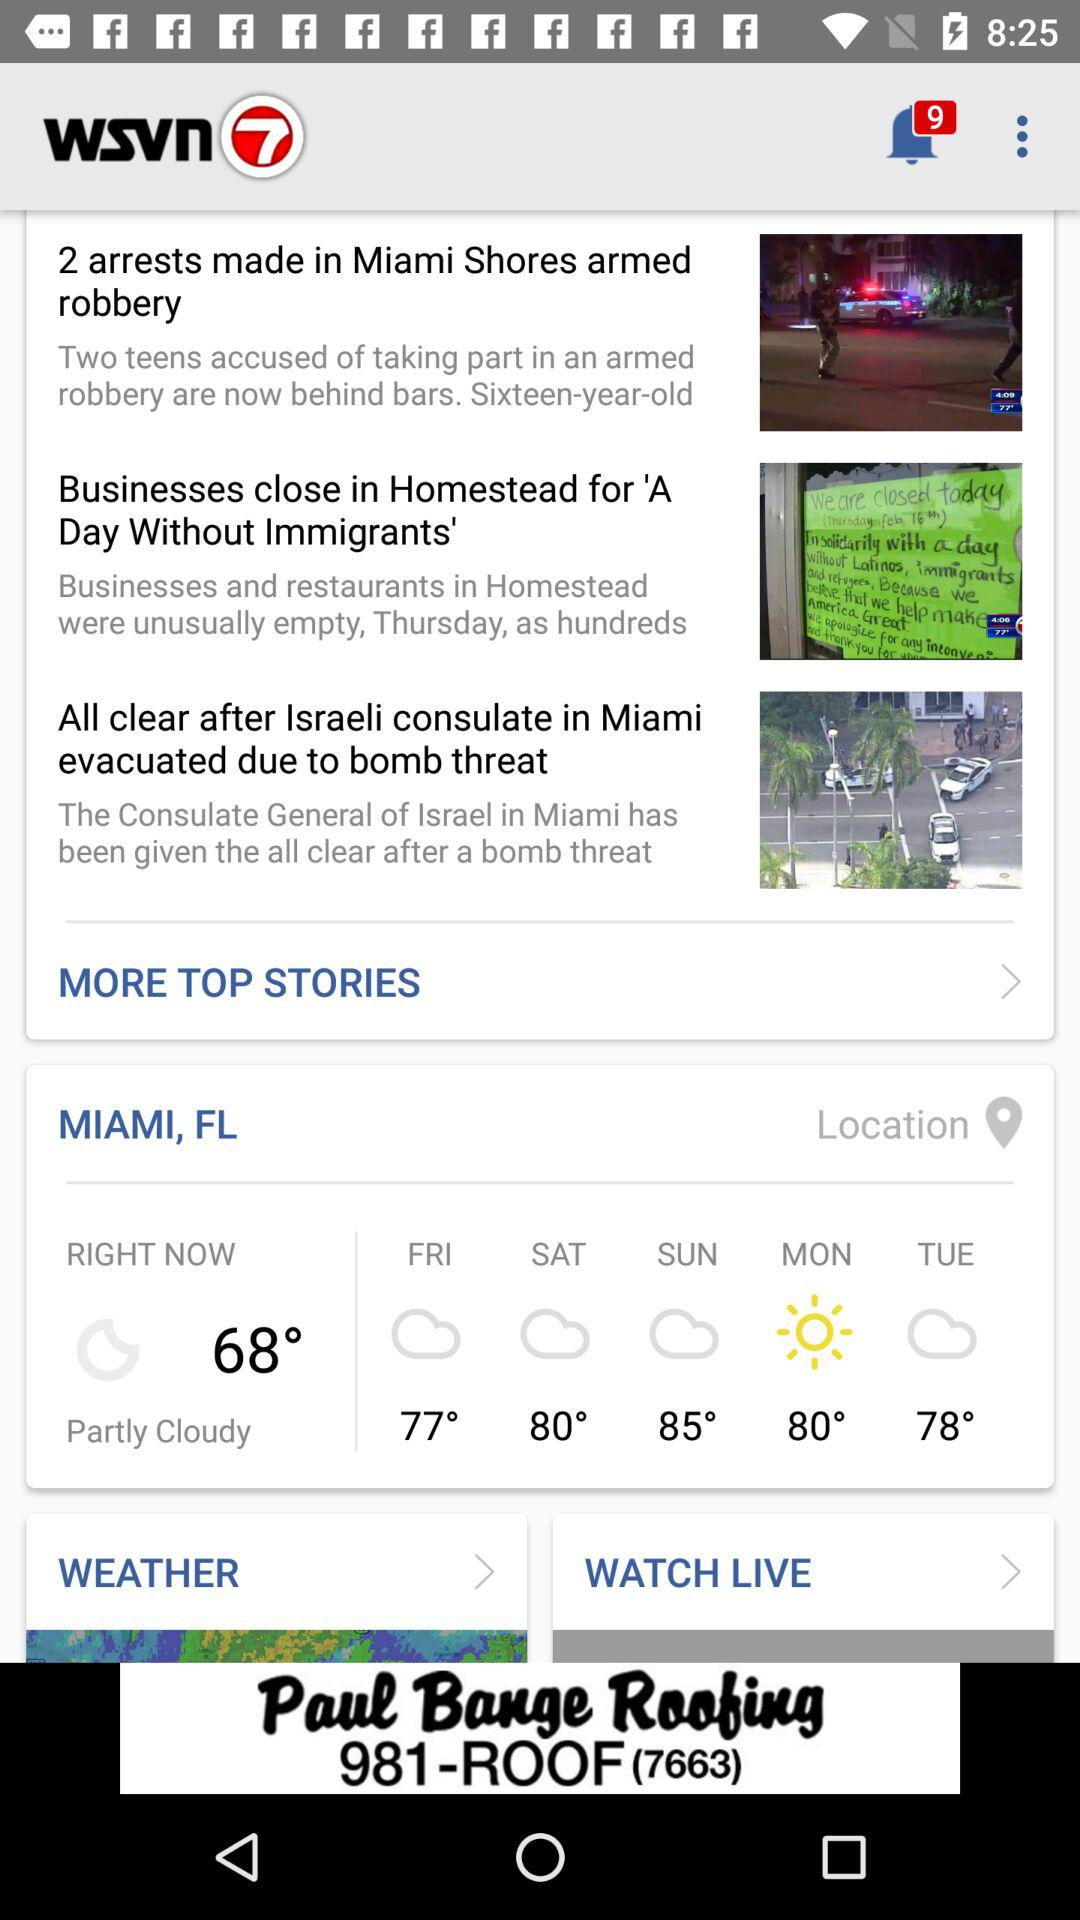What is the name of the application? The name of the application is "WSVN - 7 News Miami". 